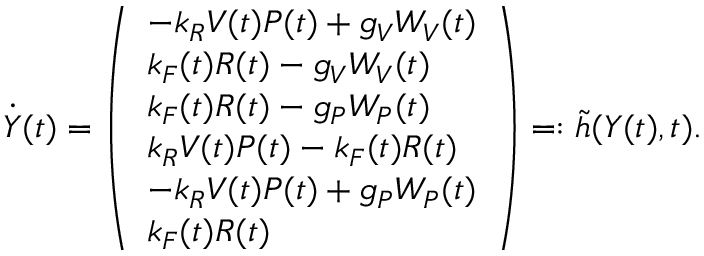<formula> <loc_0><loc_0><loc_500><loc_500>\ D o t { Y } ( t ) = \left ( \begin{array} { l } { - k _ { R } V ( t ) P ( t ) + g _ { V } W _ { V } ( t ) } \\ { k _ { F } ( t ) R ( t ) - g _ { V } W _ { V } ( t ) } \\ { k _ { F } ( t ) R ( t ) - g _ { P } W _ { P } ( t ) } \\ { k _ { R } V ( t ) P ( t ) - k _ { F } ( t ) R ( t ) } \\ { - k _ { R } V ( t ) P ( t ) + g _ { P } W _ { P } ( t ) } \\ { k _ { F } ( t ) R ( t ) } \end{array} \right ) = \colon \tilde { h } ( Y ( t ) , t ) .</formula> 